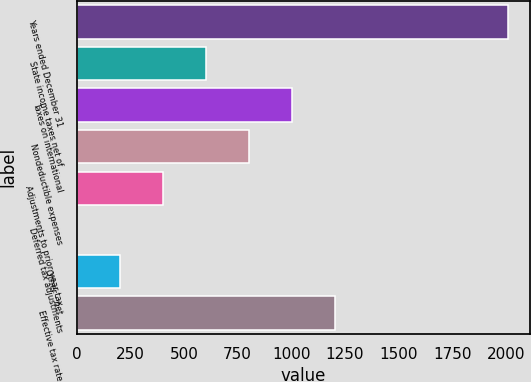Convert chart. <chart><loc_0><loc_0><loc_500><loc_500><bar_chart><fcel>Years ended December 31<fcel>State income taxes net of<fcel>Taxes on international<fcel>Nondeductible expenses<fcel>Adjustments to prior year tax<fcel>Deferred tax adjustments<fcel>Other - net<fcel>Effective tax rate<nl><fcel>2010<fcel>603.14<fcel>1005.1<fcel>804.12<fcel>402.16<fcel>0.2<fcel>201.18<fcel>1206.08<nl></chart> 